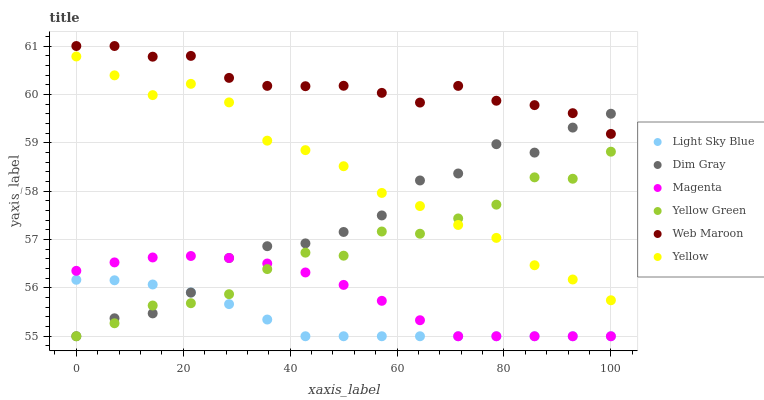Does Light Sky Blue have the minimum area under the curve?
Answer yes or no. Yes. Does Web Maroon have the maximum area under the curve?
Answer yes or no. Yes. Does Yellow Green have the minimum area under the curve?
Answer yes or no. No. Does Yellow Green have the maximum area under the curve?
Answer yes or no. No. Is Light Sky Blue the smoothest?
Answer yes or no. Yes. Is Dim Gray the roughest?
Answer yes or no. Yes. Is Yellow Green the smoothest?
Answer yes or no. No. Is Yellow Green the roughest?
Answer yes or no. No. Does Dim Gray have the lowest value?
Answer yes or no. Yes. Does Web Maroon have the lowest value?
Answer yes or no. No. Does Web Maroon have the highest value?
Answer yes or no. Yes. Does Yellow Green have the highest value?
Answer yes or no. No. Is Yellow Green less than Web Maroon?
Answer yes or no. Yes. Is Web Maroon greater than Yellow?
Answer yes or no. Yes. Does Dim Gray intersect Yellow?
Answer yes or no. Yes. Is Dim Gray less than Yellow?
Answer yes or no. No. Is Dim Gray greater than Yellow?
Answer yes or no. No. Does Yellow Green intersect Web Maroon?
Answer yes or no. No. 